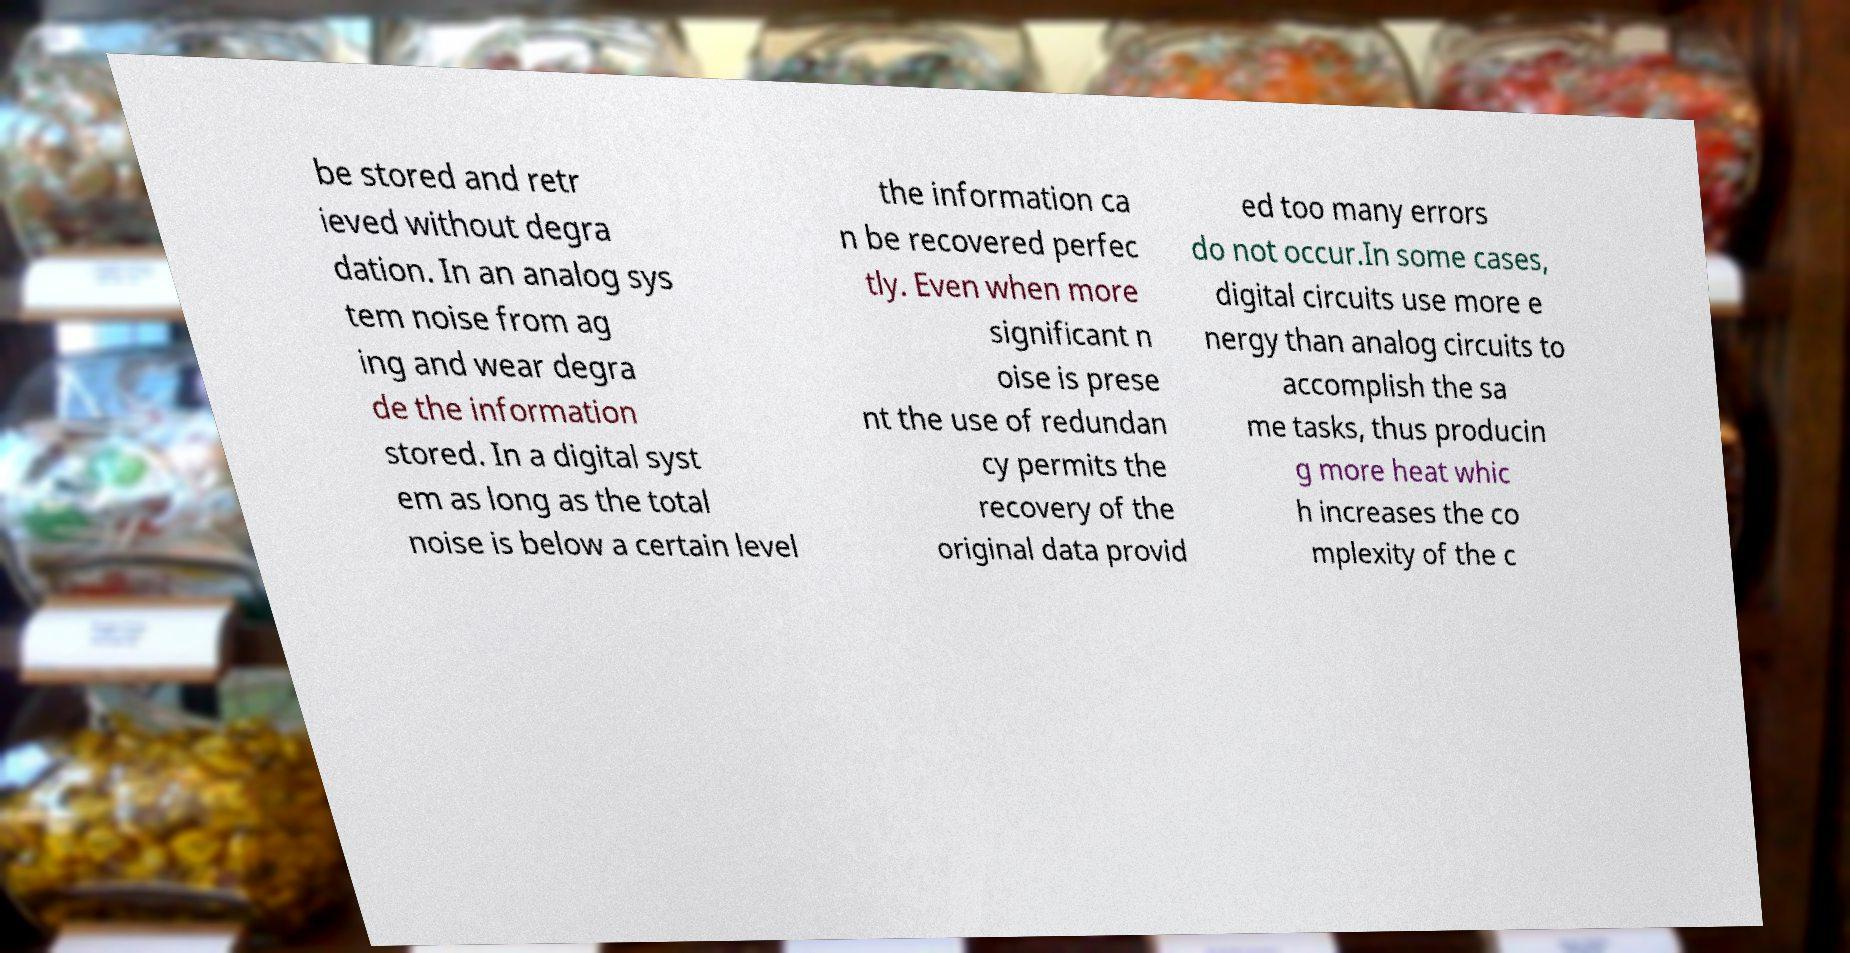Can you accurately transcribe the text from the provided image for me? be stored and retr ieved without degra dation. In an analog sys tem noise from ag ing and wear degra de the information stored. In a digital syst em as long as the total noise is below a certain level the information ca n be recovered perfec tly. Even when more significant n oise is prese nt the use of redundan cy permits the recovery of the original data provid ed too many errors do not occur.In some cases, digital circuits use more e nergy than analog circuits to accomplish the sa me tasks, thus producin g more heat whic h increases the co mplexity of the c 